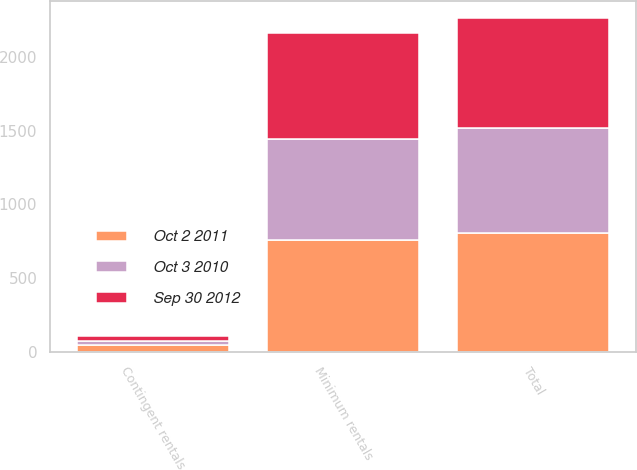Convert chart. <chart><loc_0><loc_0><loc_500><loc_500><stacked_bar_chart><ecel><fcel>Minimum rentals<fcel>Contingent rentals<fcel>Total<nl><fcel>Oct 2 2011<fcel>759<fcel>44.7<fcel>803.7<nl><fcel>Sep 30 2012<fcel>715.6<fcel>34.3<fcel>749.9<nl><fcel>Oct 3 2010<fcel>688.5<fcel>26.1<fcel>714.6<nl></chart> 